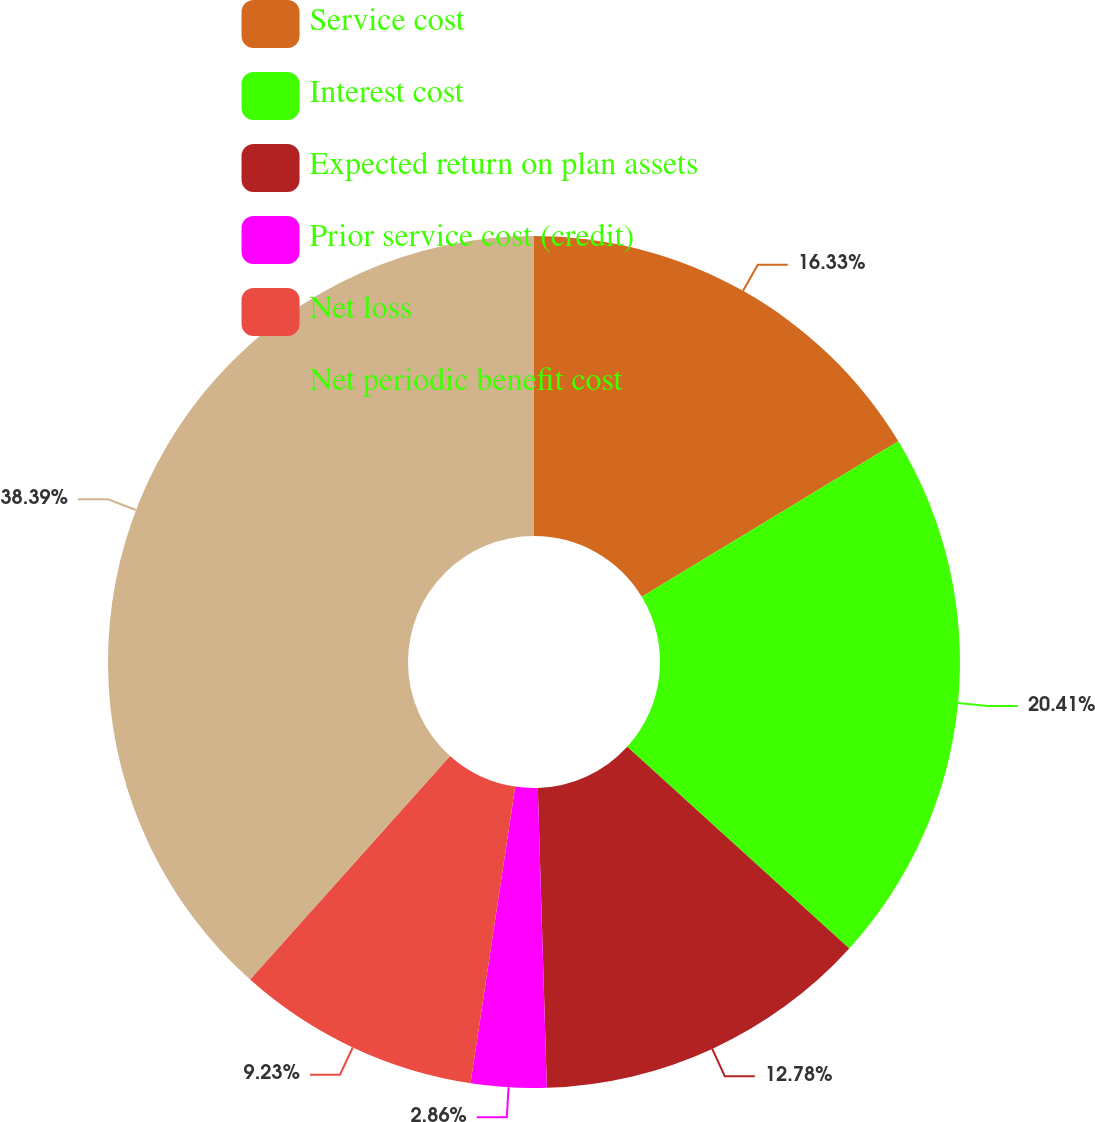<chart> <loc_0><loc_0><loc_500><loc_500><pie_chart><fcel>Service cost<fcel>Interest cost<fcel>Expected return on plan assets<fcel>Prior service cost (credit)<fcel>Net loss<fcel>Net periodic benefit cost<nl><fcel>16.33%<fcel>20.41%<fcel>12.78%<fcel>2.86%<fcel>9.23%<fcel>38.39%<nl></chart> 